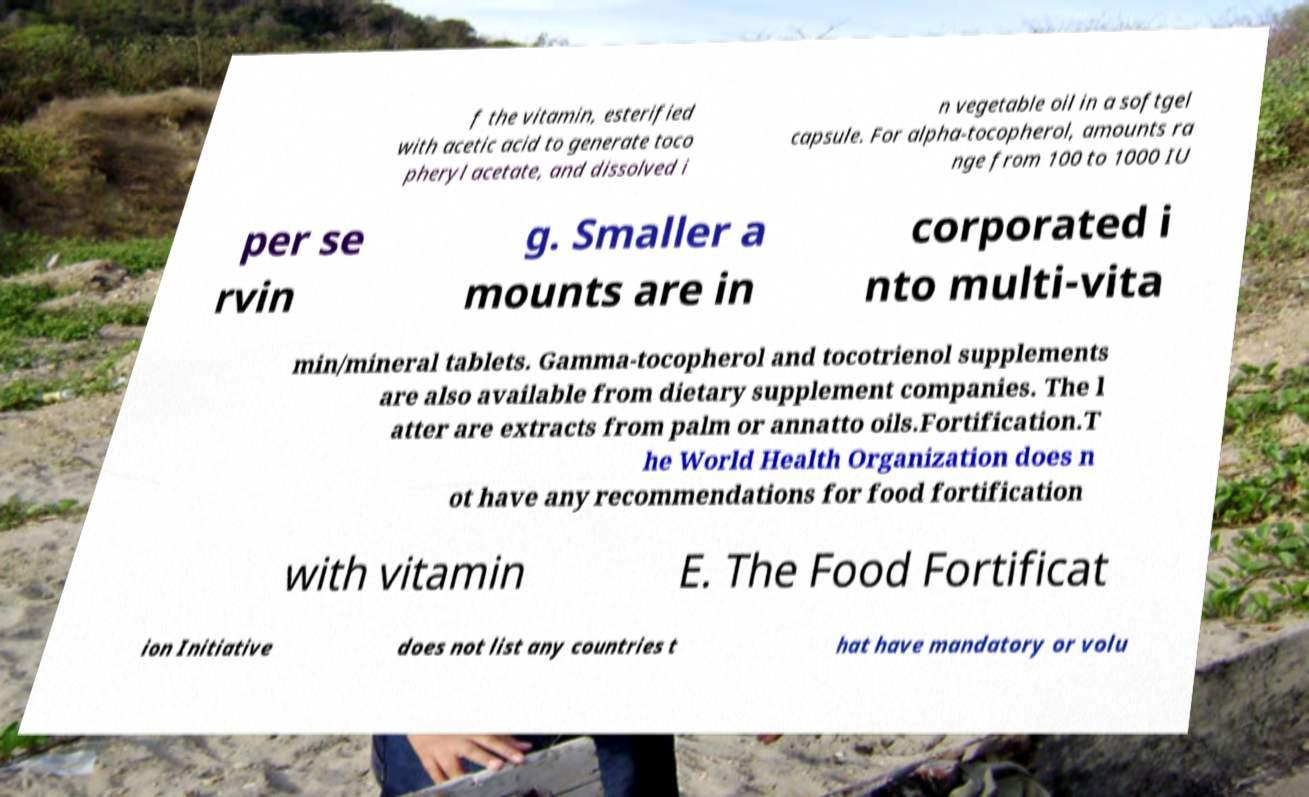Could you assist in decoding the text presented in this image and type it out clearly? f the vitamin, esterified with acetic acid to generate toco pheryl acetate, and dissolved i n vegetable oil in a softgel capsule. For alpha-tocopherol, amounts ra nge from 100 to 1000 IU per se rvin g. Smaller a mounts are in corporated i nto multi-vita min/mineral tablets. Gamma-tocopherol and tocotrienol supplements are also available from dietary supplement companies. The l atter are extracts from palm or annatto oils.Fortification.T he World Health Organization does n ot have any recommendations for food fortification with vitamin E. The Food Fortificat ion Initiative does not list any countries t hat have mandatory or volu 